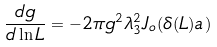Convert formula to latex. <formula><loc_0><loc_0><loc_500><loc_500>\frac { d g } { d \ln L } = - 2 \pi g ^ { 2 } \lambda _ { 3 } ^ { 2 } J _ { o } ( \delta ( L ) a )</formula> 